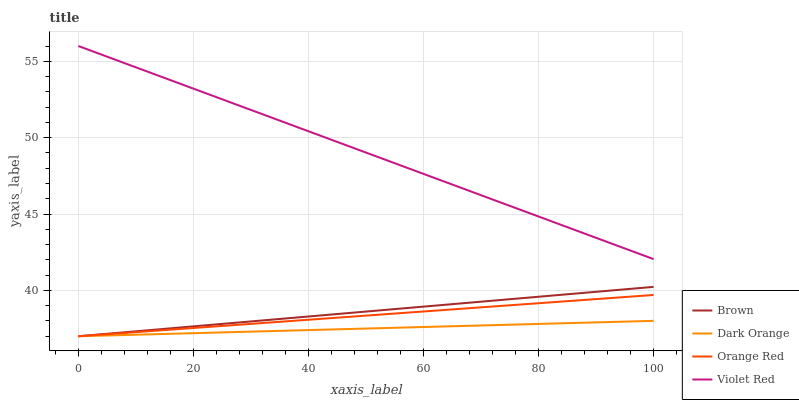Does Dark Orange have the minimum area under the curve?
Answer yes or no. Yes. Does Violet Red have the maximum area under the curve?
Answer yes or no. Yes. Does Orange Red have the minimum area under the curve?
Answer yes or no. No. Does Orange Red have the maximum area under the curve?
Answer yes or no. No. Is Brown the smoothest?
Answer yes or no. Yes. Is Dark Orange the roughest?
Answer yes or no. Yes. Is Violet Red the smoothest?
Answer yes or no. No. Is Violet Red the roughest?
Answer yes or no. No. Does Brown have the lowest value?
Answer yes or no. Yes. Does Violet Red have the lowest value?
Answer yes or no. No. Does Violet Red have the highest value?
Answer yes or no. Yes. Does Orange Red have the highest value?
Answer yes or no. No. Is Dark Orange less than Violet Red?
Answer yes or no. Yes. Is Violet Red greater than Orange Red?
Answer yes or no. Yes. Does Orange Red intersect Dark Orange?
Answer yes or no. Yes. Is Orange Red less than Dark Orange?
Answer yes or no. No. Is Orange Red greater than Dark Orange?
Answer yes or no. No. Does Dark Orange intersect Violet Red?
Answer yes or no. No. 